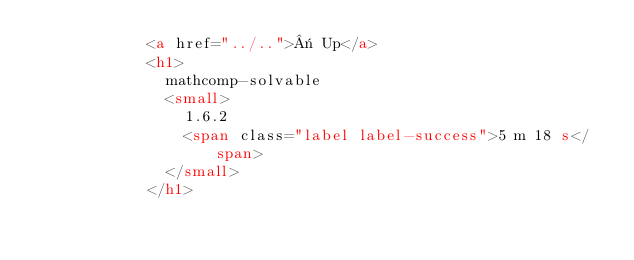<code> <loc_0><loc_0><loc_500><loc_500><_HTML_>            <a href="../..">« Up</a>
            <h1>
              mathcomp-solvable
              <small>
                1.6.2
                <span class="label label-success">5 m 18 s</span>
              </small>
            </h1></code> 